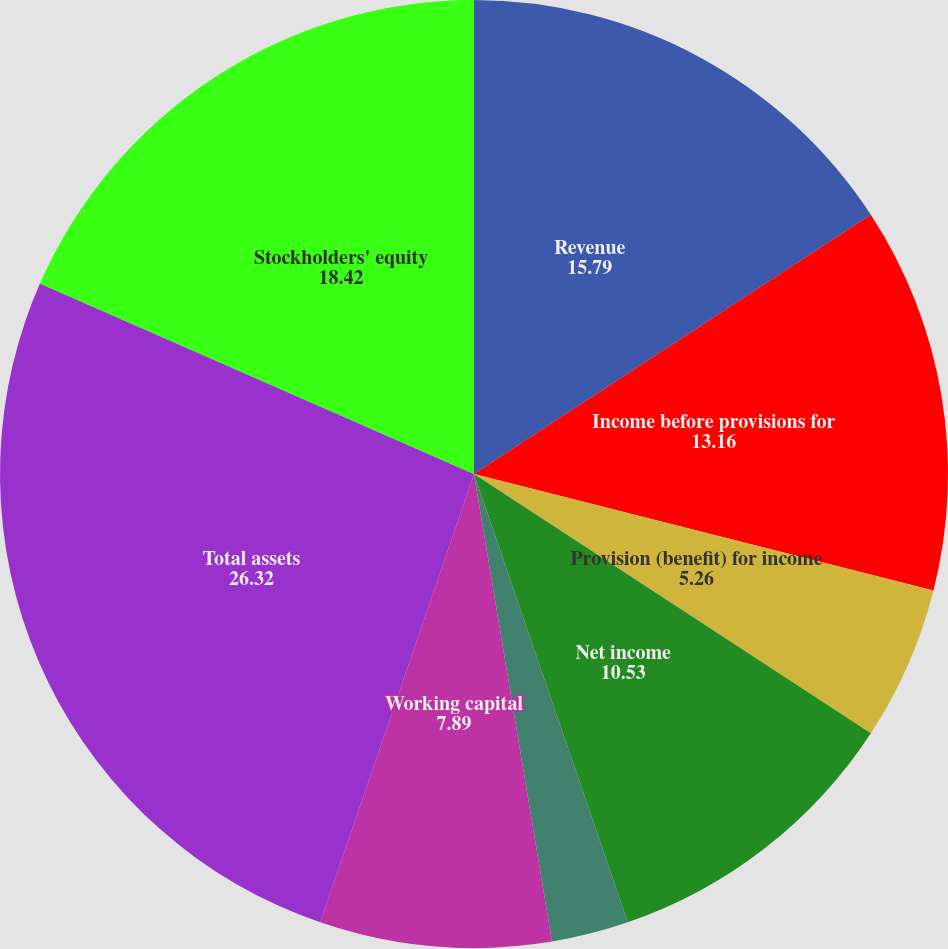<chart> <loc_0><loc_0><loc_500><loc_500><pie_chart><fcel>Revenue<fcel>Income before provisions for<fcel>Provision (benefit) for income<fcel>Net income<fcel>Basic<fcel>Diluted<fcel>Working capital<fcel>Total assets<fcel>Stockholders' equity<nl><fcel>15.79%<fcel>13.16%<fcel>5.26%<fcel>10.53%<fcel>2.63%<fcel>0.0%<fcel>7.89%<fcel>26.32%<fcel>18.42%<nl></chart> 